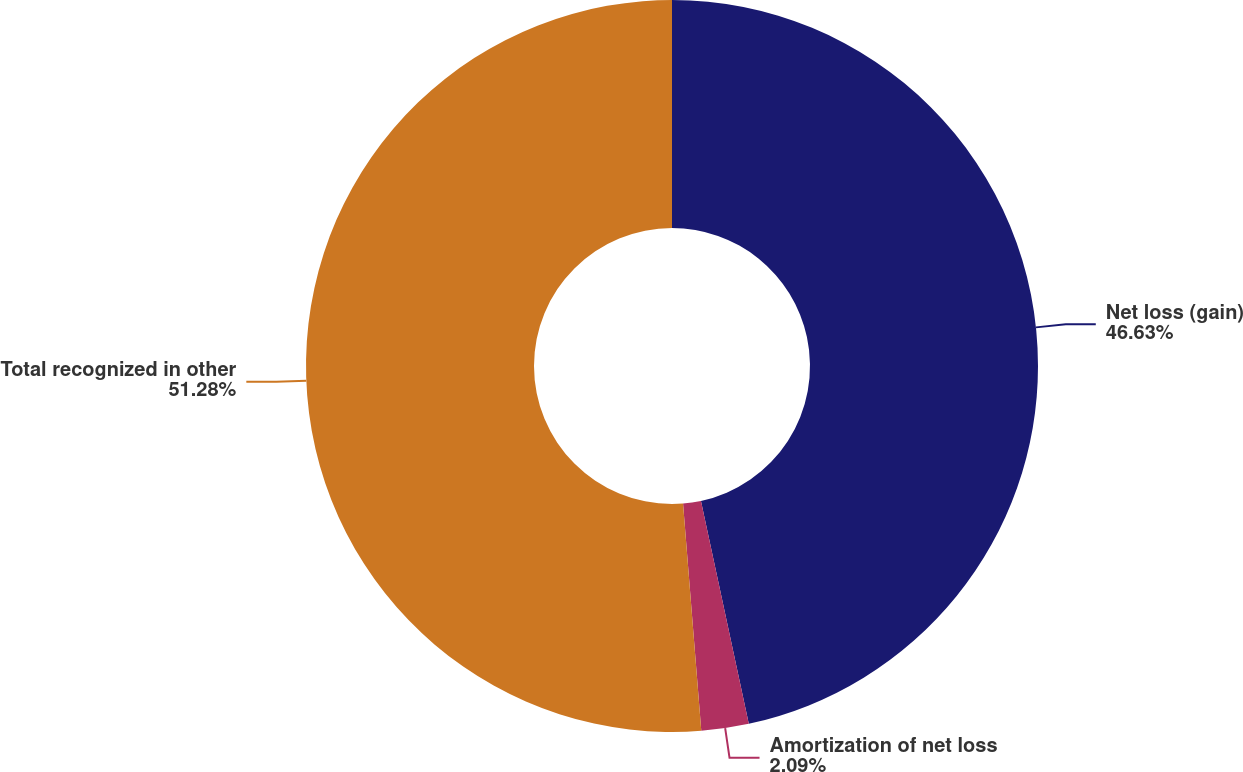<chart> <loc_0><loc_0><loc_500><loc_500><pie_chart><fcel>Net loss (gain)<fcel>Amortization of net loss<fcel>Total recognized in other<nl><fcel>46.63%<fcel>2.09%<fcel>51.27%<nl></chart> 